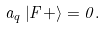Convert formula to latex. <formula><loc_0><loc_0><loc_500><loc_500>a _ { q } \left | F + \right > = 0 .</formula> 